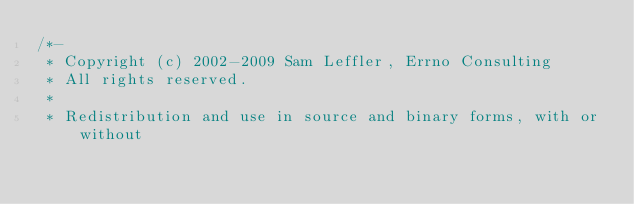<code> <loc_0><loc_0><loc_500><loc_500><_C_>/*-
 * Copyright (c) 2002-2009 Sam Leffler, Errno Consulting
 * All rights reserved.
 *
 * Redistribution and use in source and binary forms, with or without</code> 